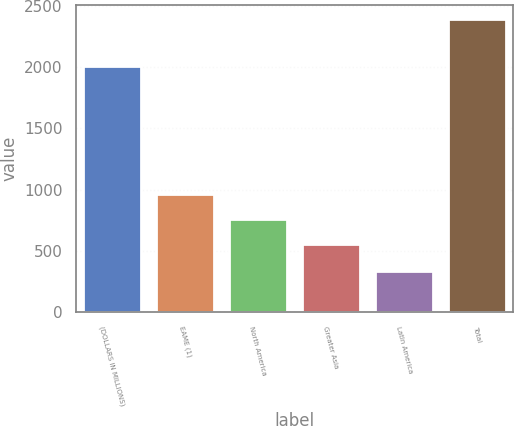<chart> <loc_0><loc_0><loc_500><loc_500><bar_chart><fcel>(DOLLARS IN MILLIONS)<fcel>EAME (1)<fcel>North America<fcel>Greater Asia<fcel>Latin America<fcel>Total<nl><fcel>2008<fcel>967<fcel>761.5<fcel>556<fcel>334<fcel>2389<nl></chart> 